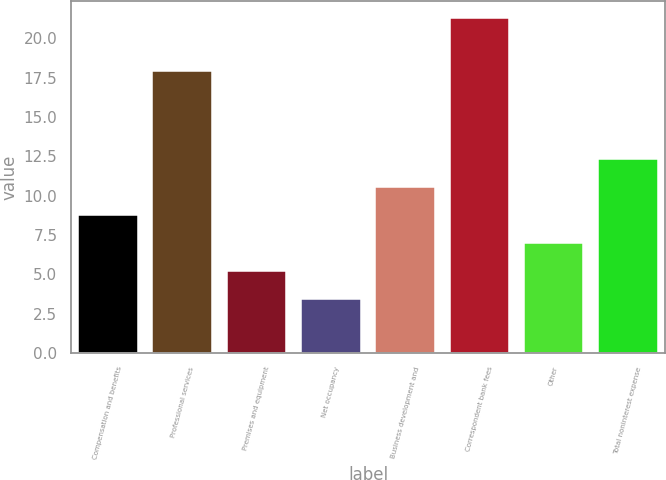Convert chart. <chart><loc_0><loc_0><loc_500><loc_500><bar_chart><fcel>Compensation and benefits<fcel>Professional services<fcel>Premises and equipment<fcel>Net occupancy<fcel>Business development and<fcel>Correspondent bank fees<fcel>Other<fcel>Total noninterest expense<nl><fcel>8.77<fcel>17.9<fcel>5.19<fcel>3.4<fcel>10.56<fcel>21.3<fcel>6.98<fcel>12.35<nl></chart> 